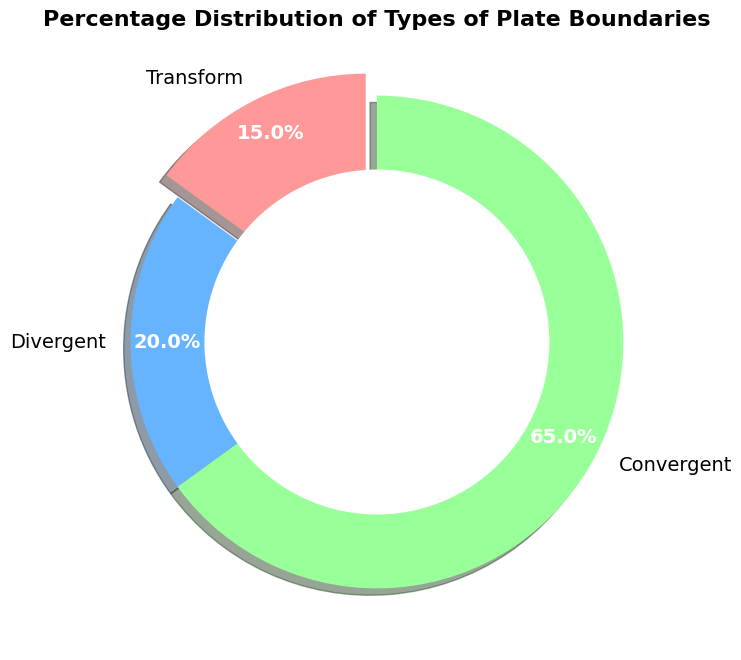What is the percentage of convergent plate boundaries? According to the figure, the percentage of convergent plate boundaries is labeled directly on the pie chart as 65%.
Answer: 65% Which type of plate boundary has the smallest percentage? By examining the pie chart, the smallest segment corresponds to the Transform plate boundaries, labeled as 15%.
Answer: Transform What is the combined percentage of Transform and Divergent plate boundaries? The pie chart shows the Transform plate boundaries at 15% and Divergent at 20%. Adding these two percentages together gives 15% + 20% = 35%.
Answer: 35% Which plate boundary type has an exploded slice in the pie chart? The figure shows that the Transform plate boundary's slice is separated slightly from the rest, indicating it is "exploded".
Answer: Transform How does the percentage of Divergent plate boundaries compare to Convergent plate boundaries? The pie chart indicates that Divergent plate boundaries account for 20% and Convergent for 65%. 20% is less than 65%, so Divergent plate boundaries have a smaller percentage than Convergent.
Answer: Divergent has a smaller percentage than Convergent By what percentage does the Convergent plate boundary exceed the Divergent plate boundary? The percentage of Convergent plate boundaries is 65% and Divergent is 20%. Subtracting the two gives 65% - 20% = 45%.
Answer: 45% What is the second most common type of plate boundary according to the chart? The chart shows Convergent plate boundaries at 65%, Divergent at 20%, and Transform at 15%. The second largest segment is Divergent at 20%.
Answer: Divergent What is the total percentage represented by the pie chart, and why is it significant? A pie chart should represent the entire dataset, thus the total percentage is typically 100%. Adding 65% (Convergent) + 20% (Divergent) + 15% (Transform) equals 100%, confirming the chart accurately represents the distribution.
Answer: 100% If the Transform and Divergent boundaries were combined into a single category, what percentage would it represent? Combining Transform (15%) and Divergent (20%) boundaries results in 15% + 20% = 35%.
Answer: 35% How does the shadowing effect in the pie chart help emphasize the data? The shadowing effect creates a 3D appearance, which helps distinguish the slices from each other, making it easier to see and interpret different sections of the pie chart.
Answer: It enhances slice distinction 